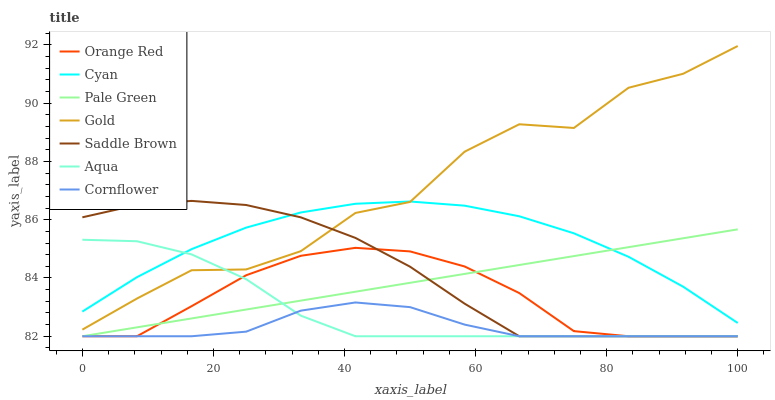Does Aqua have the minimum area under the curve?
Answer yes or no. No. Does Aqua have the maximum area under the curve?
Answer yes or no. No. Is Aqua the smoothest?
Answer yes or no. No. Is Aqua the roughest?
Answer yes or no. No. Does Gold have the lowest value?
Answer yes or no. No. Does Aqua have the highest value?
Answer yes or no. No. Is Orange Red less than Cyan?
Answer yes or no. Yes. Is Cyan greater than Orange Red?
Answer yes or no. Yes. Does Orange Red intersect Cyan?
Answer yes or no. No. 